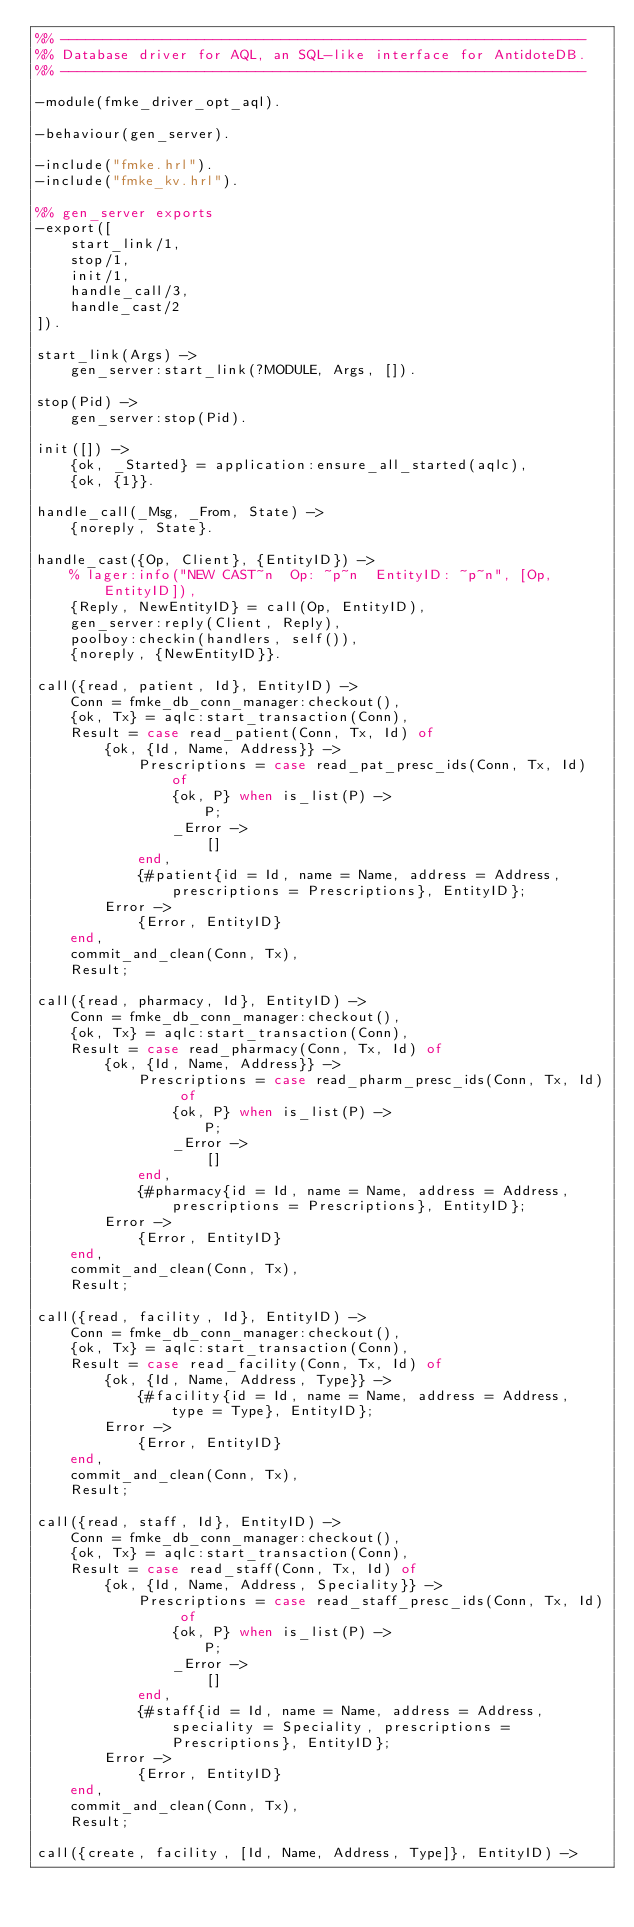<code> <loc_0><loc_0><loc_500><loc_500><_Erlang_>%% --------------------------------------------------------------
%% Database driver for AQL, an SQL-like interface for AntidoteDB.
%% --------------------------------------------------------------

-module(fmke_driver_opt_aql).

-behaviour(gen_server).

-include("fmke.hrl").
-include("fmke_kv.hrl").

%% gen_server exports
-export([
    start_link/1,
    stop/1,
    init/1,
    handle_call/3,
    handle_cast/2
]).

start_link(Args) ->
    gen_server:start_link(?MODULE, Args, []).

stop(Pid) ->
    gen_server:stop(Pid).

init([]) ->
    {ok, _Started} = application:ensure_all_started(aqlc),
    {ok, {1}}.

handle_call(_Msg, _From, State) ->
    {noreply, State}.

handle_cast({Op, Client}, {EntityID}) ->
    % lager:info("NEW CAST~n  Op: ~p~n  EntityID: ~p~n", [Op, EntityID]),
    {Reply, NewEntityID} = call(Op, EntityID),
    gen_server:reply(Client, Reply),
    poolboy:checkin(handlers, self()),
    {noreply, {NewEntityID}}.

call({read, patient, Id}, EntityID) ->
    Conn = fmke_db_conn_manager:checkout(),
    {ok, Tx} = aqlc:start_transaction(Conn),
    Result = case read_patient(Conn, Tx, Id) of
        {ok, {Id, Name, Address}} ->
            Prescriptions = case read_pat_presc_ids(Conn, Tx, Id) of
                {ok, P} when is_list(P) ->
                    P;
                _Error ->
                    []
            end,
            {#patient{id = Id, name = Name, address = Address, prescriptions = Prescriptions}, EntityID};
        Error ->
            {Error, EntityID}
    end,
    commit_and_clean(Conn, Tx),
    Result;

call({read, pharmacy, Id}, EntityID) ->
    Conn = fmke_db_conn_manager:checkout(),
    {ok, Tx} = aqlc:start_transaction(Conn),
    Result = case read_pharmacy(Conn, Tx, Id) of
        {ok, {Id, Name, Address}} ->
            Prescriptions = case read_pharm_presc_ids(Conn, Tx, Id) of
                {ok, P} when is_list(P) ->
                    P;
                _Error ->
                    []
            end,
            {#pharmacy{id = Id, name = Name, address = Address, prescriptions = Prescriptions}, EntityID};
        Error ->
            {Error, EntityID}
    end,
    commit_and_clean(Conn, Tx),
    Result;

call({read, facility, Id}, EntityID) ->
    Conn = fmke_db_conn_manager:checkout(),
    {ok, Tx} = aqlc:start_transaction(Conn),
    Result = case read_facility(Conn, Tx, Id) of
        {ok, {Id, Name, Address, Type}} ->
            {#facility{id = Id, name = Name, address = Address, type = Type}, EntityID};
        Error ->
            {Error, EntityID}
    end,
    commit_and_clean(Conn, Tx),
    Result;

call({read, staff, Id}, EntityID) ->
    Conn = fmke_db_conn_manager:checkout(),
    {ok, Tx} = aqlc:start_transaction(Conn),
    Result = case read_staff(Conn, Tx, Id) of
        {ok, {Id, Name, Address, Speciality}} ->
            Prescriptions = case read_staff_presc_ids(Conn, Tx, Id) of
                {ok, P} when is_list(P) ->
                    P;
                _Error ->
                    []
            end,
            {#staff{id = Id, name = Name, address = Address, speciality = Speciality, prescriptions = Prescriptions}, EntityID};
        Error ->
            {Error, EntityID}
    end,
    commit_and_clean(Conn, Tx),
    Result;

call({create, facility, [Id, Name, Address, Type]}, EntityID) -></code> 